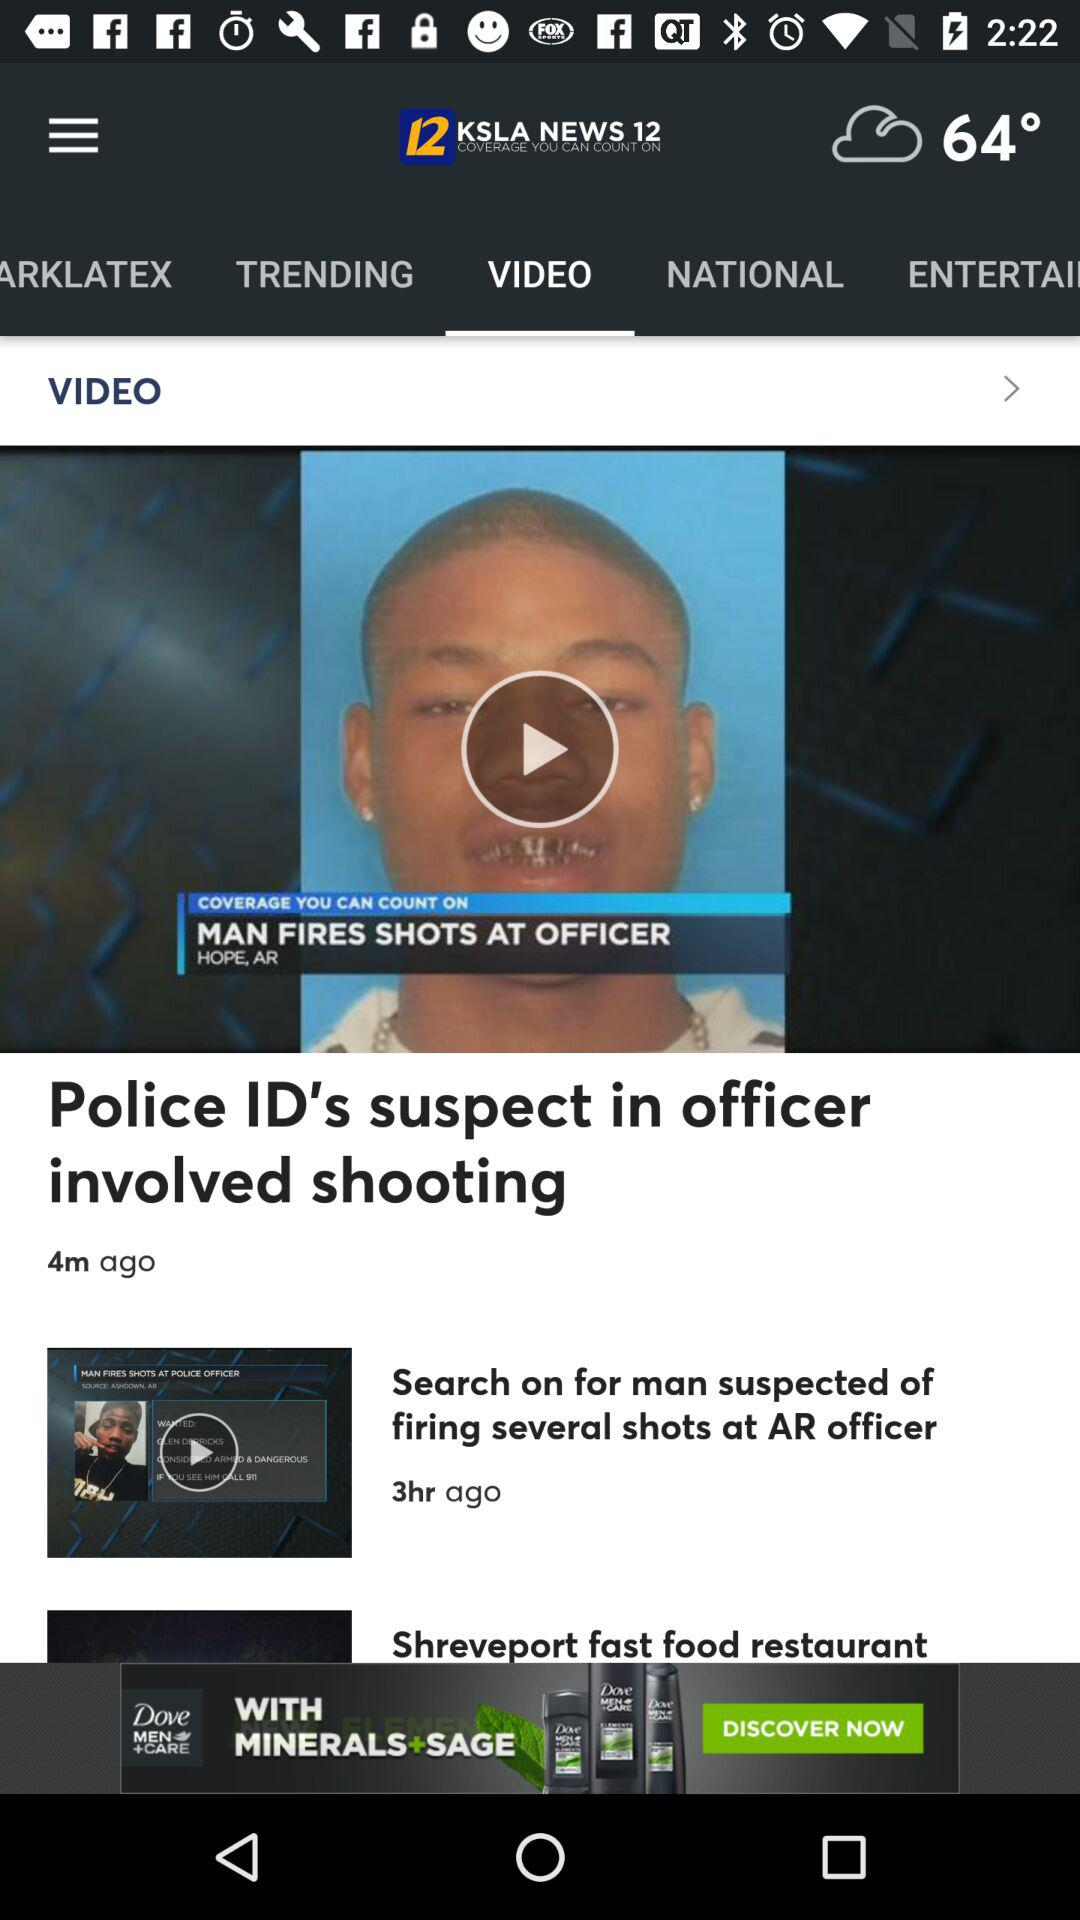What is the title of the video that was posted 4 minutes ago? The title of the video that was posted 4 minutes ago is "Police ID's suspect in officer involved shooting". 